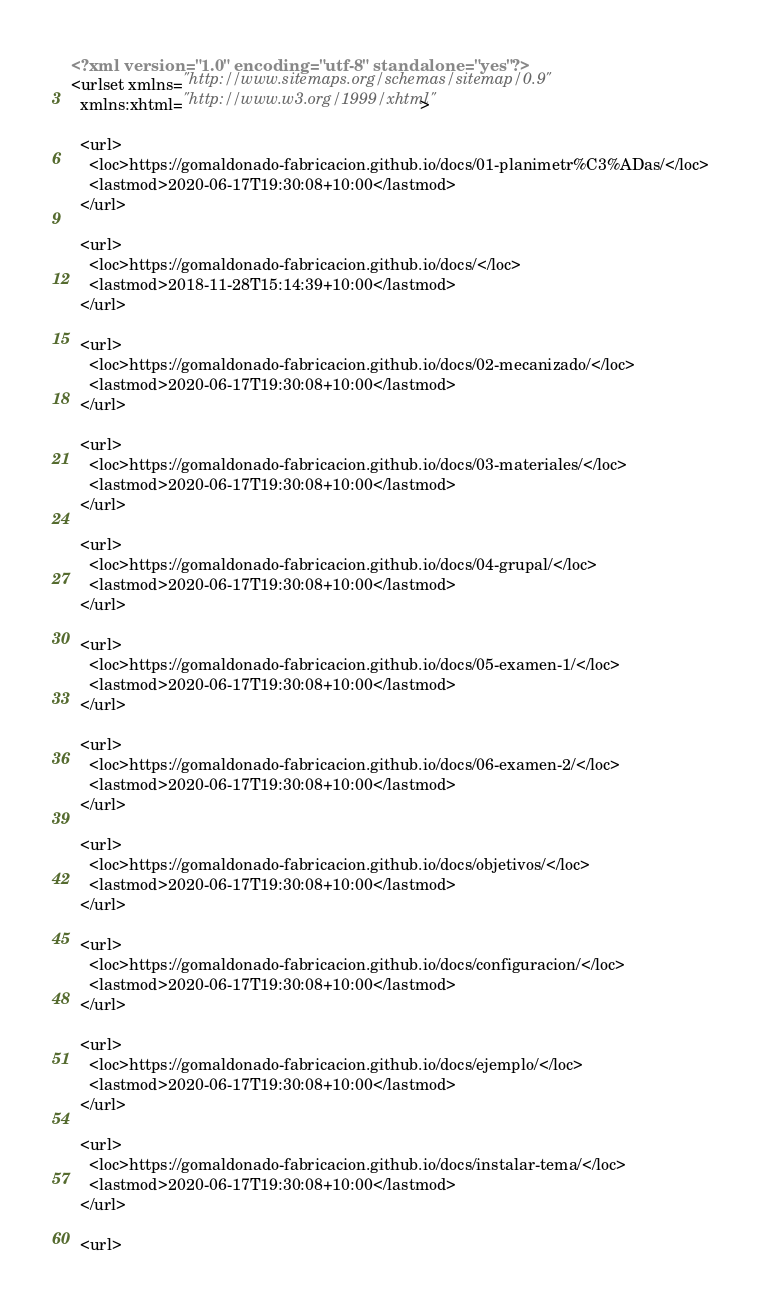<code> <loc_0><loc_0><loc_500><loc_500><_XML_><?xml version="1.0" encoding="utf-8" standalone="yes"?>
<urlset xmlns="http://www.sitemaps.org/schemas/sitemap/0.9"
  xmlns:xhtml="http://www.w3.org/1999/xhtml">
  
  <url>
    <loc>https://gomaldonado-fabricacion.github.io/docs/01-planimetr%C3%ADas/</loc>
    <lastmod>2020-06-17T19:30:08+10:00</lastmod>
  </url>
  
  <url>
    <loc>https://gomaldonado-fabricacion.github.io/docs/</loc>
    <lastmod>2018-11-28T15:14:39+10:00</lastmod>
  </url>
  
  <url>
    <loc>https://gomaldonado-fabricacion.github.io/docs/02-mecanizado/</loc>
    <lastmod>2020-06-17T19:30:08+10:00</lastmod>
  </url>
  
  <url>
    <loc>https://gomaldonado-fabricacion.github.io/docs/03-materiales/</loc>
    <lastmod>2020-06-17T19:30:08+10:00</lastmod>
  </url>
  
  <url>
    <loc>https://gomaldonado-fabricacion.github.io/docs/04-grupal/</loc>
    <lastmod>2020-06-17T19:30:08+10:00</lastmod>
  </url>
  
  <url>
    <loc>https://gomaldonado-fabricacion.github.io/docs/05-examen-1/</loc>
    <lastmod>2020-06-17T19:30:08+10:00</lastmod>
  </url>
  
  <url>
    <loc>https://gomaldonado-fabricacion.github.io/docs/06-examen-2/</loc>
    <lastmod>2020-06-17T19:30:08+10:00</lastmod>
  </url>
  
  <url>
    <loc>https://gomaldonado-fabricacion.github.io/docs/objetivos/</loc>
    <lastmod>2020-06-17T19:30:08+10:00</lastmod>
  </url>
  
  <url>
    <loc>https://gomaldonado-fabricacion.github.io/docs/configuracion/</loc>
    <lastmod>2020-06-17T19:30:08+10:00</lastmod>
  </url>
  
  <url>
    <loc>https://gomaldonado-fabricacion.github.io/docs/ejemplo/</loc>
    <lastmod>2020-06-17T19:30:08+10:00</lastmod>
  </url>
  
  <url>
    <loc>https://gomaldonado-fabricacion.github.io/docs/instalar-tema/</loc>
    <lastmod>2020-06-17T19:30:08+10:00</lastmod>
  </url>
  
  <url></code> 